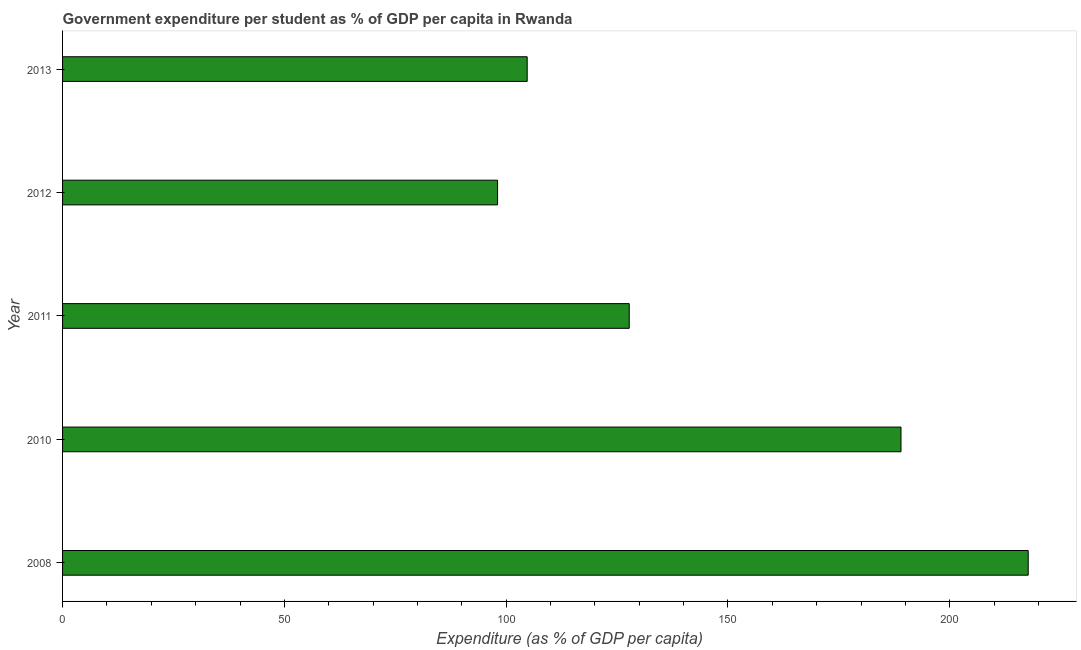Does the graph contain any zero values?
Make the answer very short. No. Does the graph contain grids?
Offer a very short reply. No. What is the title of the graph?
Ensure brevity in your answer.  Government expenditure per student as % of GDP per capita in Rwanda. What is the label or title of the X-axis?
Keep it short and to the point. Expenditure (as % of GDP per capita). What is the government expenditure per student in 2010?
Ensure brevity in your answer.  189.02. Across all years, what is the maximum government expenditure per student?
Offer a terse response. 217.7. Across all years, what is the minimum government expenditure per student?
Give a very brief answer. 98.07. In which year was the government expenditure per student maximum?
Your response must be concise. 2008. In which year was the government expenditure per student minimum?
Offer a terse response. 2012. What is the sum of the government expenditure per student?
Give a very brief answer. 737.28. What is the difference between the government expenditure per student in 2011 and 2012?
Provide a succinct answer. 29.68. What is the average government expenditure per student per year?
Your answer should be very brief. 147.46. What is the median government expenditure per student?
Provide a short and direct response. 127.75. What is the ratio of the government expenditure per student in 2008 to that in 2011?
Provide a succinct answer. 1.7. Is the government expenditure per student in 2010 less than that in 2011?
Provide a succinct answer. No. What is the difference between the highest and the second highest government expenditure per student?
Your response must be concise. 28.68. What is the difference between the highest and the lowest government expenditure per student?
Keep it short and to the point. 119.63. How many bars are there?
Offer a terse response. 5. What is the difference between two consecutive major ticks on the X-axis?
Give a very brief answer. 50. Are the values on the major ticks of X-axis written in scientific E-notation?
Your response must be concise. No. What is the Expenditure (as % of GDP per capita) in 2008?
Your answer should be very brief. 217.7. What is the Expenditure (as % of GDP per capita) of 2010?
Your answer should be very brief. 189.02. What is the Expenditure (as % of GDP per capita) of 2011?
Provide a short and direct response. 127.75. What is the Expenditure (as % of GDP per capita) of 2012?
Your answer should be compact. 98.07. What is the Expenditure (as % of GDP per capita) in 2013?
Keep it short and to the point. 104.75. What is the difference between the Expenditure (as % of GDP per capita) in 2008 and 2010?
Your response must be concise. 28.68. What is the difference between the Expenditure (as % of GDP per capita) in 2008 and 2011?
Offer a terse response. 89.95. What is the difference between the Expenditure (as % of GDP per capita) in 2008 and 2012?
Your answer should be very brief. 119.63. What is the difference between the Expenditure (as % of GDP per capita) in 2008 and 2013?
Make the answer very short. 112.95. What is the difference between the Expenditure (as % of GDP per capita) in 2010 and 2011?
Offer a very short reply. 61.27. What is the difference between the Expenditure (as % of GDP per capita) in 2010 and 2012?
Provide a succinct answer. 90.95. What is the difference between the Expenditure (as % of GDP per capita) in 2010 and 2013?
Provide a succinct answer. 84.27. What is the difference between the Expenditure (as % of GDP per capita) in 2011 and 2012?
Your response must be concise. 29.68. What is the difference between the Expenditure (as % of GDP per capita) in 2011 and 2013?
Ensure brevity in your answer.  23.01. What is the difference between the Expenditure (as % of GDP per capita) in 2012 and 2013?
Your response must be concise. -6.68. What is the ratio of the Expenditure (as % of GDP per capita) in 2008 to that in 2010?
Keep it short and to the point. 1.15. What is the ratio of the Expenditure (as % of GDP per capita) in 2008 to that in 2011?
Your answer should be compact. 1.7. What is the ratio of the Expenditure (as % of GDP per capita) in 2008 to that in 2012?
Your answer should be compact. 2.22. What is the ratio of the Expenditure (as % of GDP per capita) in 2008 to that in 2013?
Your response must be concise. 2.08. What is the ratio of the Expenditure (as % of GDP per capita) in 2010 to that in 2011?
Provide a succinct answer. 1.48. What is the ratio of the Expenditure (as % of GDP per capita) in 2010 to that in 2012?
Provide a succinct answer. 1.93. What is the ratio of the Expenditure (as % of GDP per capita) in 2010 to that in 2013?
Offer a terse response. 1.8. What is the ratio of the Expenditure (as % of GDP per capita) in 2011 to that in 2012?
Offer a very short reply. 1.3. What is the ratio of the Expenditure (as % of GDP per capita) in 2011 to that in 2013?
Offer a very short reply. 1.22. What is the ratio of the Expenditure (as % of GDP per capita) in 2012 to that in 2013?
Offer a very short reply. 0.94. 